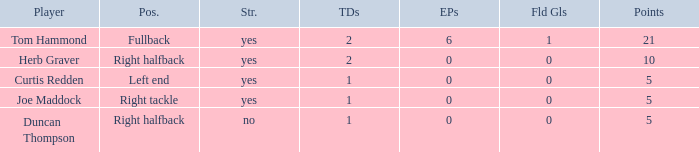Would you mind parsing the complete table? {'header': ['Player', 'Pos.', 'Str.', 'TDs', 'EPs', 'Fld Gls', 'Points'], 'rows': [['Tom Hammond', 'Fullback', 'yes', '2', '6', '1', '21'], ['Herb Graver', 'Right halfback', 'yes', '2', '0', '0', '10'], ['Curtis Redden', 'Left end', 'yes', '1', '0', '0', '5'], ['Joe Maddock', 'Right tackle', 'yes', '1', '0', '0', '5'], ['Duncan Thompson', 'Right halfback', 'no', '1', '0', '0', '5']]} Name the starter for position being left end Yes. 